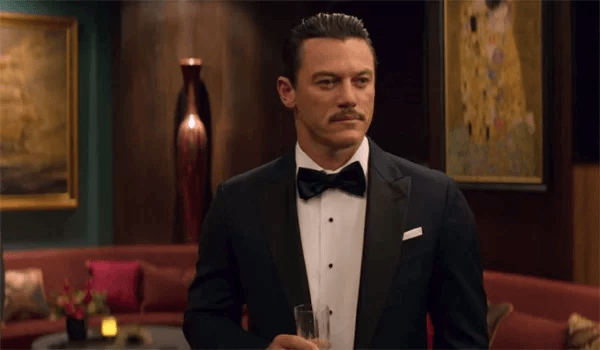What might the serious expression on his face suggest about the context of this image? The man's serious expression could indicate he is at a significant social event, possibly reflecting on an important personal decision or preparing for a momentous occasion. The formal setting and his demeanor might suggest he's involved in an event where decorum and poise are crucial. 